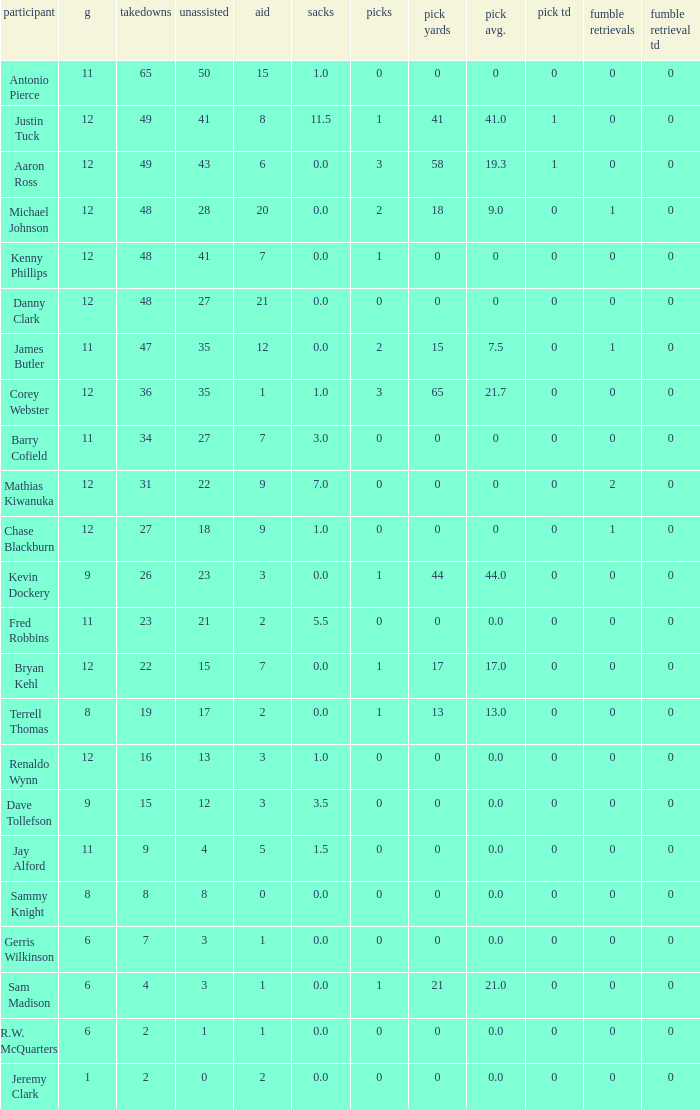Identify the lowest tackle count for danny clark. 48.0. 